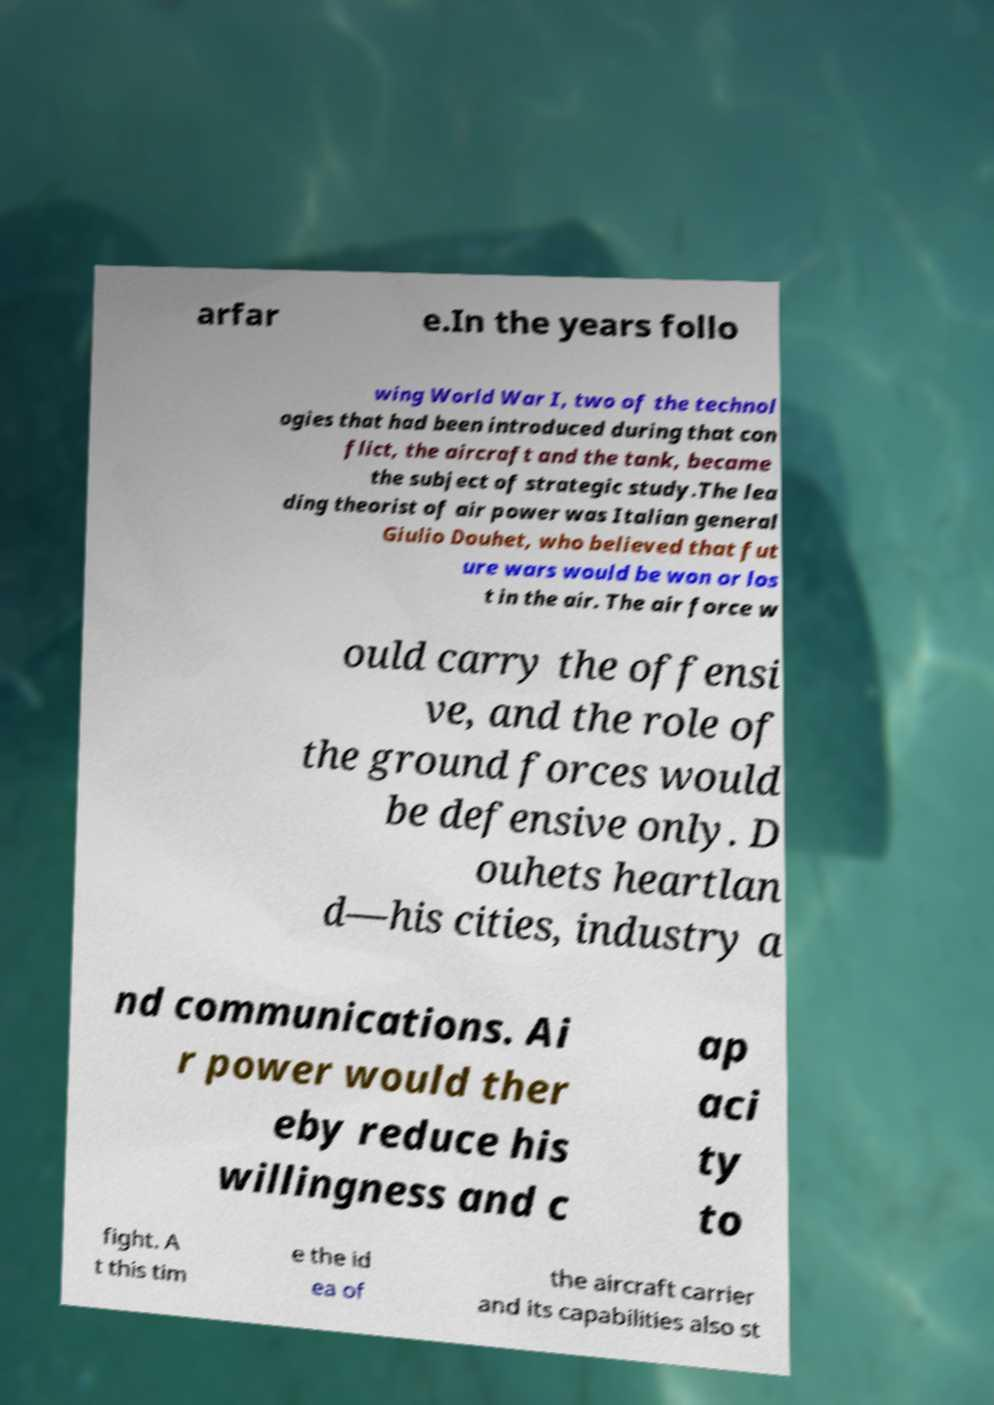Could you extract and type out the text from this image? arfar e.In the years follo wing World War I, two of the technol ogies that had been introduced during that con flict, the aircraft and the tank, became the subject of strategic study.The lea ding theorist of air power was Italian general Giulio Douhet, who believed that fut ure wars would be won or los t in the air. The air force w ould carry the offensi ve, and the role of the ground forces would be defensive only. D ouhets heartlan d—his cities, industry a nd communications. Ai r power would ther eby reduce his willingness and c ap aci ty to fight. A t this tim e the id ea of the aircraft carrier and its capabilities also st 